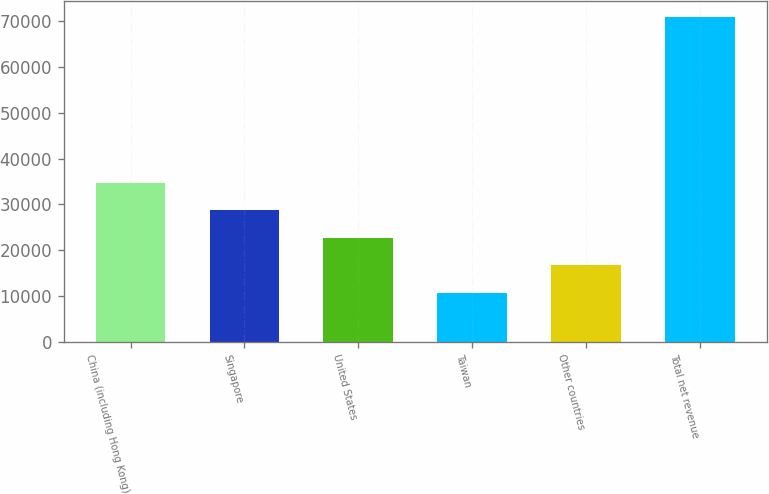Convert chart. <chart><loc_0><loc_0><loc_500><loc_500><bar_chart><fcel>China (including Hong Kong)<fcel>Singapore<fcel>United States<fcel>Taiwan<fcel>Other countries<fcel>Total net revenue<nl><fcel>34726.8<fcel>28706.6<fcel>22686.4<fcel>10646<fcel>16666.2<fcel>70848<nl></chart> 